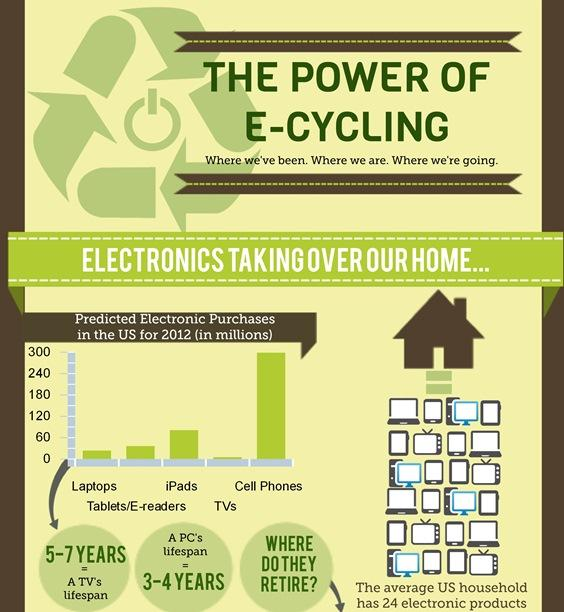Outline some significant characteristics in this image. The following three devices have sold fewer than 60 million units: laptops, TVs, and tablets/e-readers. There are two devices that have purchased more than 60 million units each. These devices are cell phones and iPads. The device with the lowest predicted electronic purchase is TVs. The lifespan of a TV is estimated to be between 5 and 7 years. According to my prediction, the device with the second highest predicted electronic purchase is the iPad. 